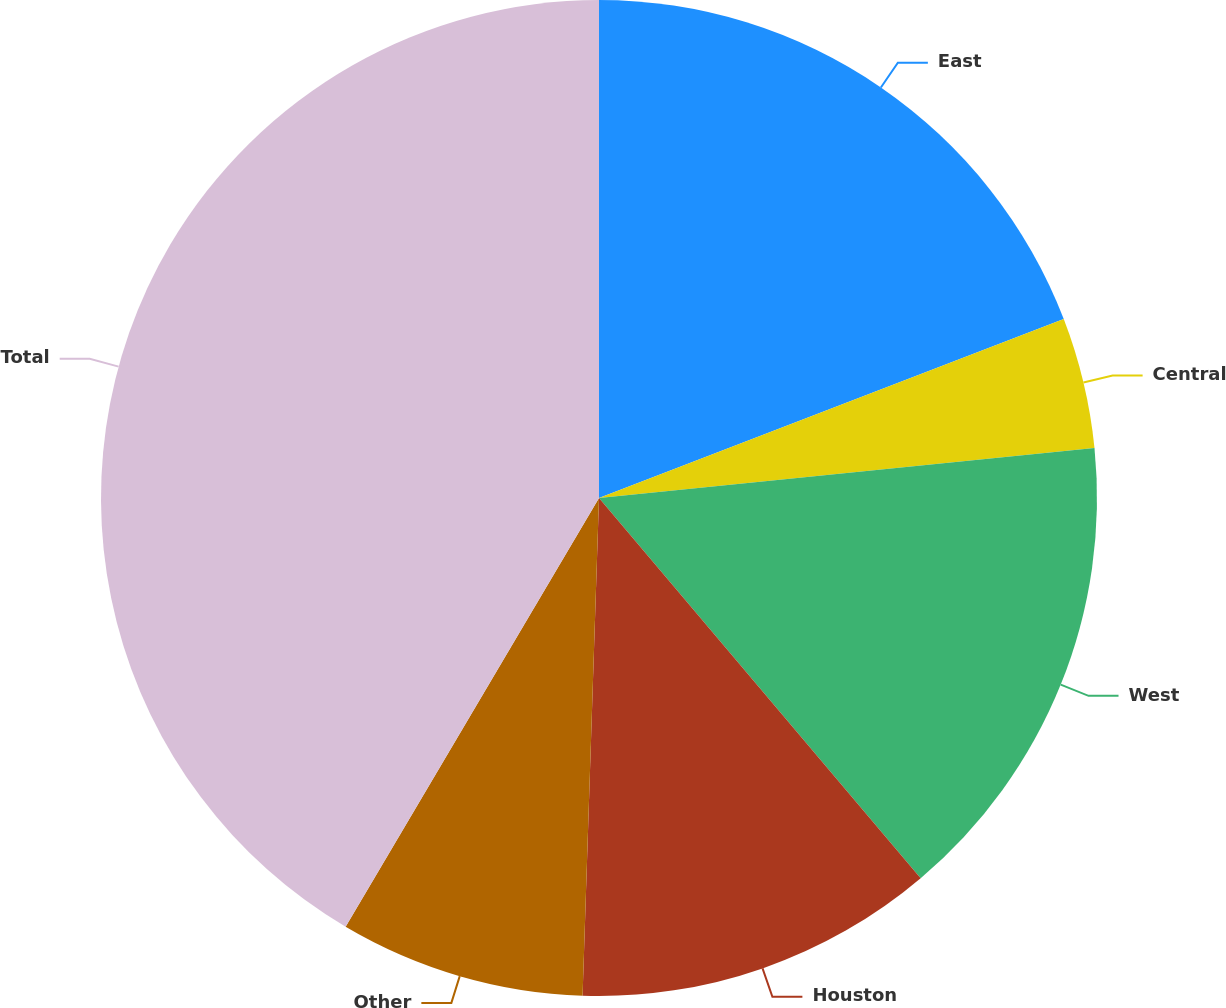Convert chart to OTSL. <chart><loc_0><loc_0><loc_500><loc_500><pie_chart><fcel>East<fcel>Central<fcel>West<fcel>Houston<fcel>Other<fcel>Total<nl><fcel>19.15%<fcel>4.25%<fcel>15.42%<fcel>11.7%<fcel>7.97%<fcel>41.5%<nl></chart> 